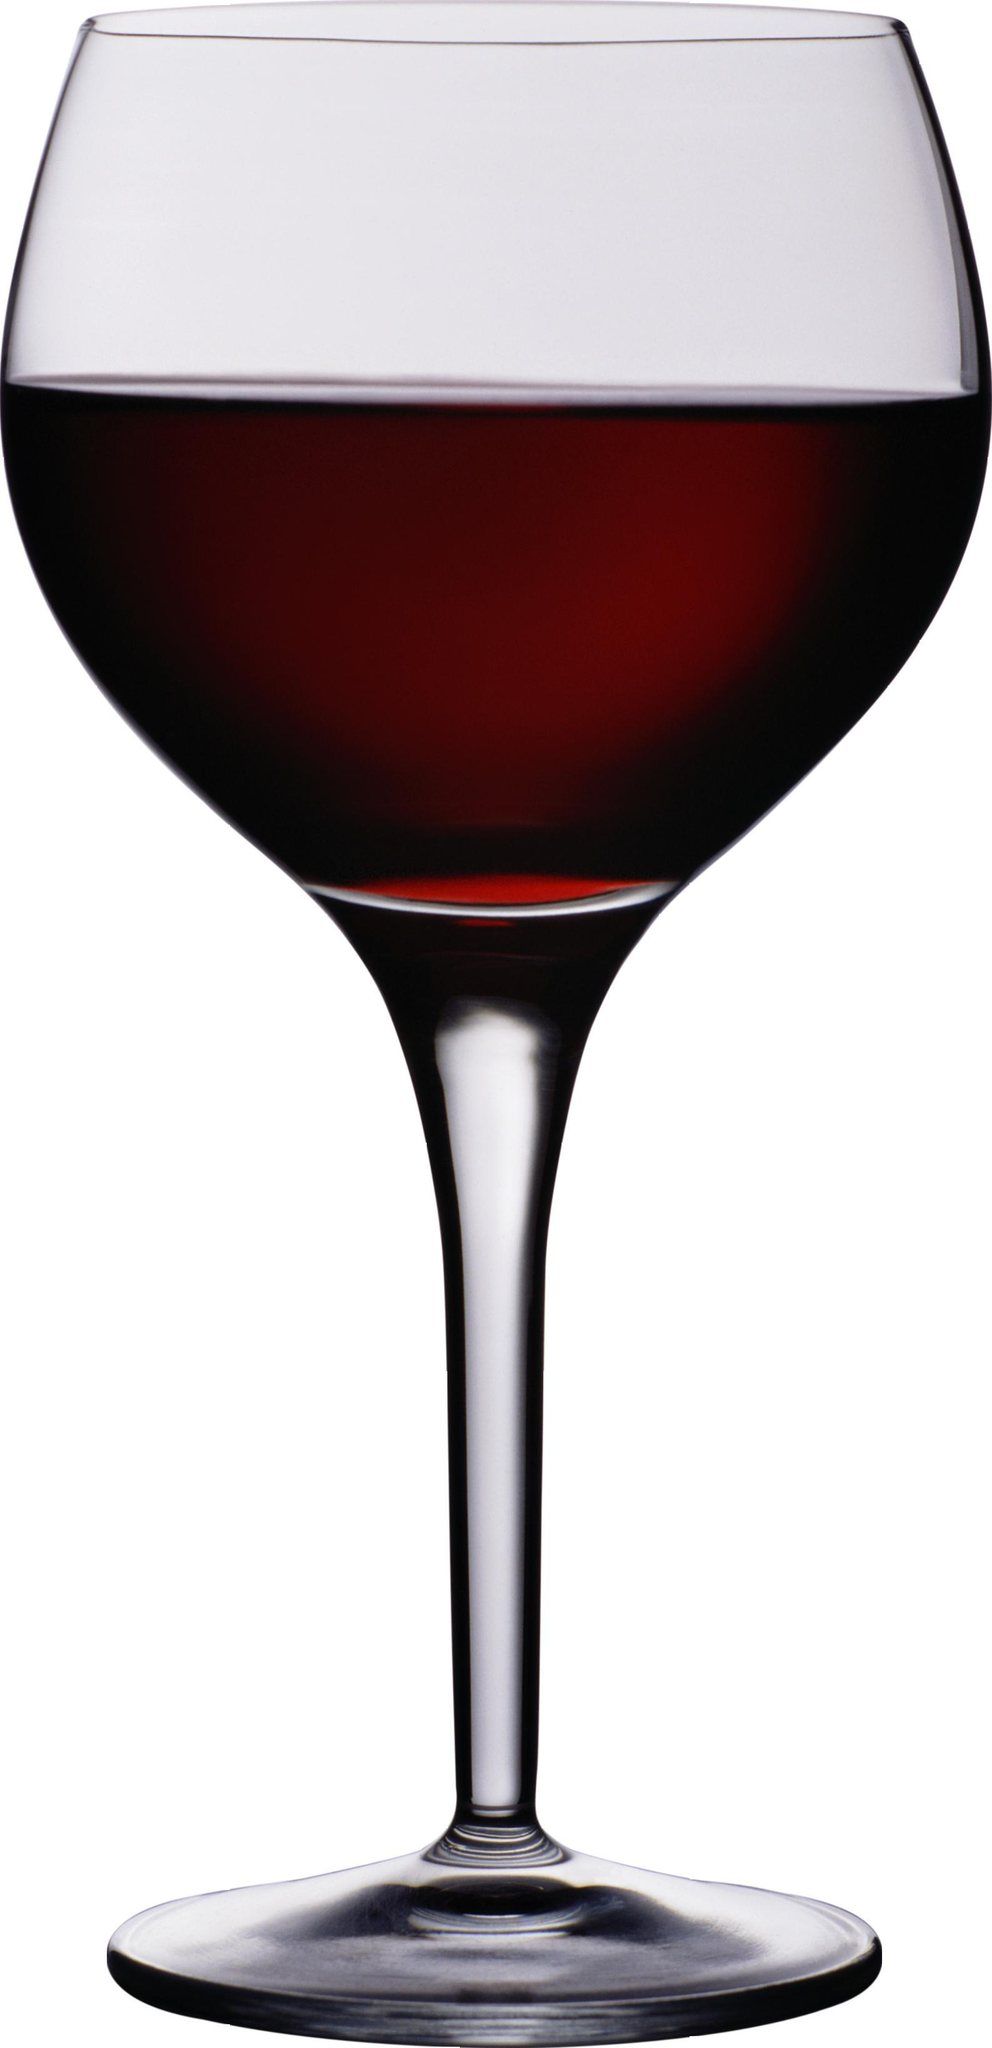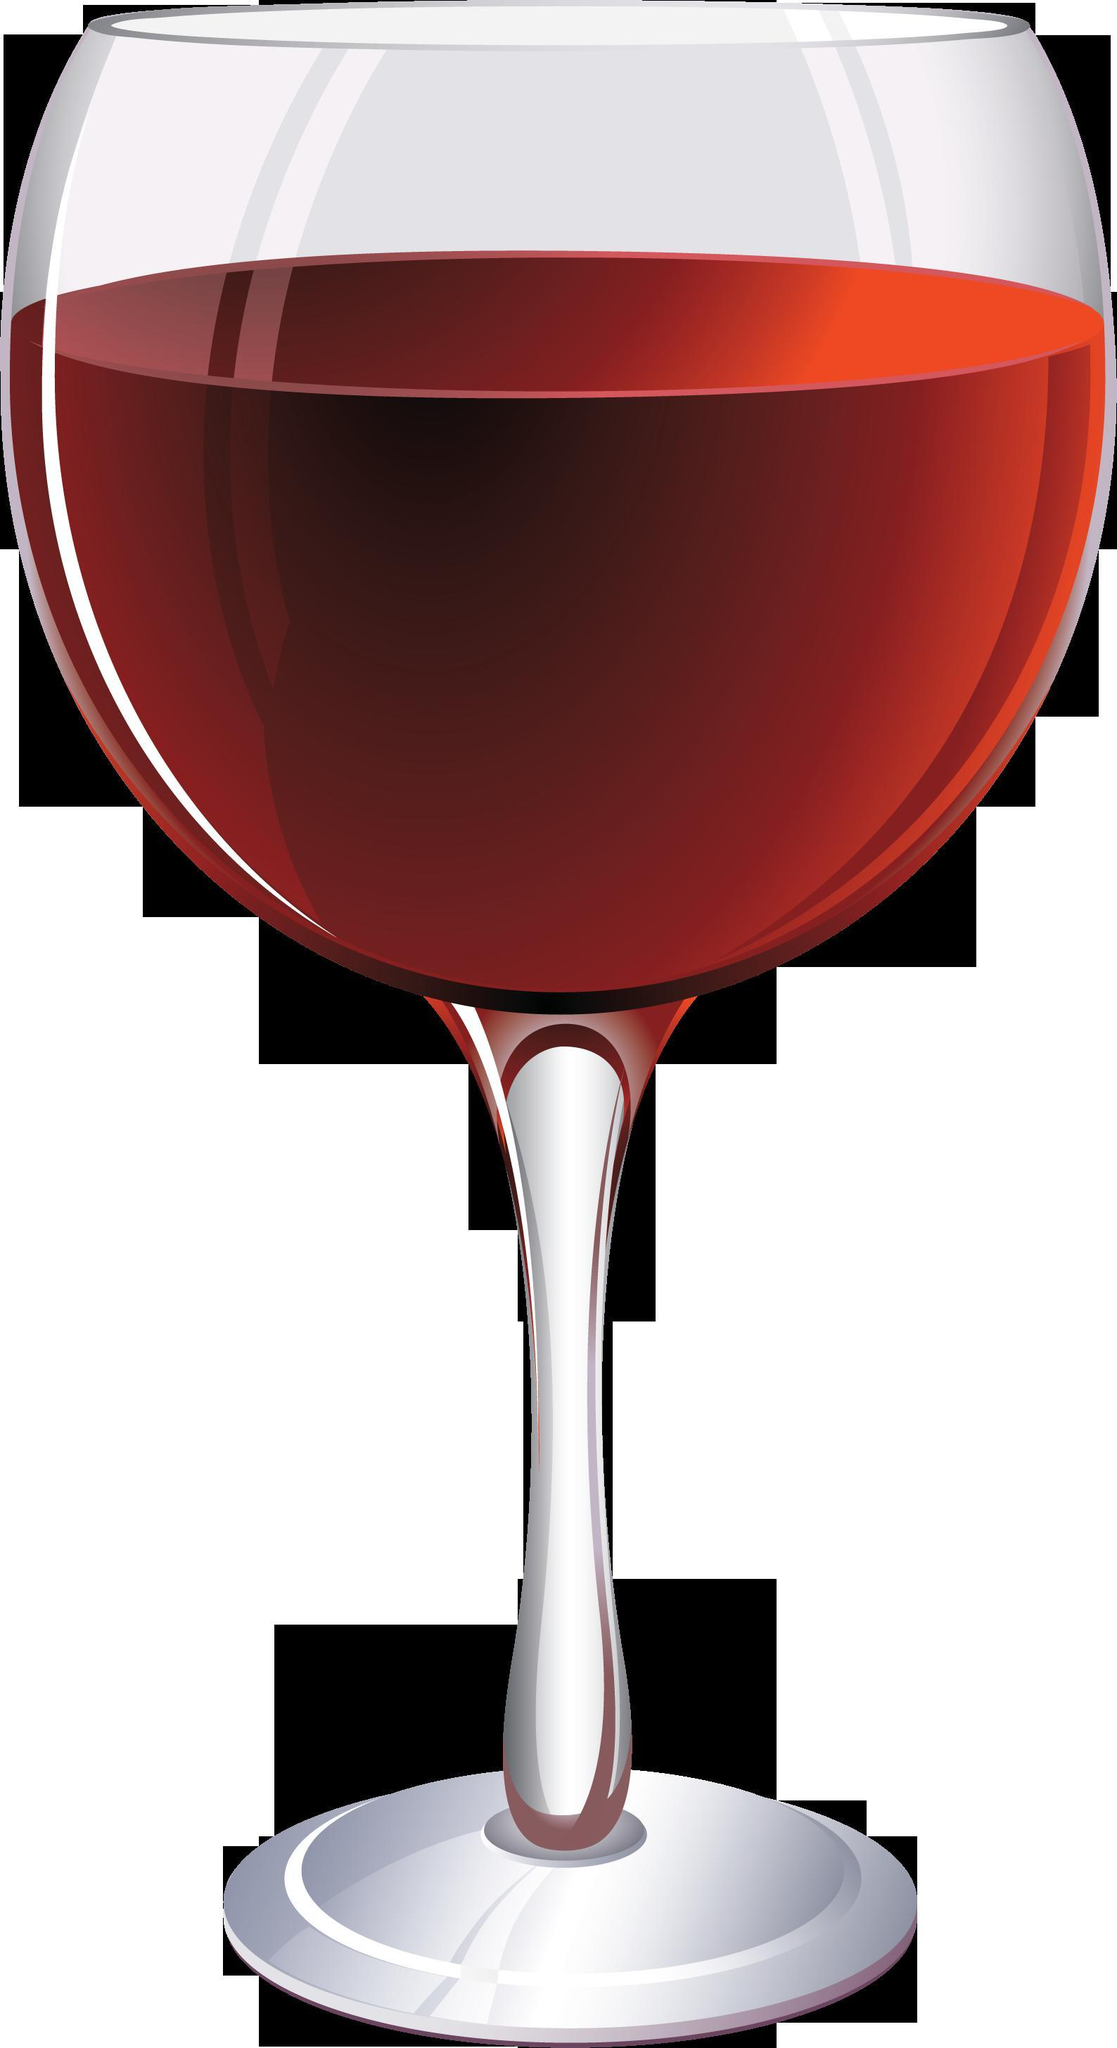The first image is the image on the left, the second image is the image on the right. Assess this claim about the two images: "The left image shows two glasses of red wine while the right image shows one". Correct or not? Answer yes or no. No. The first image is the image on the left, the second image is the image on the right. Examine the images to the left and right. Is the description "There is at least two wine glasses in the left image." accurate? Answer yes or no. No. 